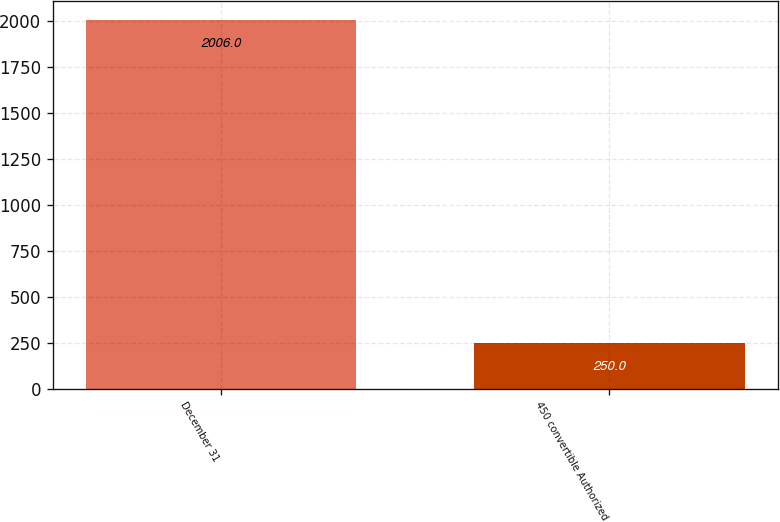Convert chart to OTSL. <chart><loc_0><loc_0><loc_500><loc_500><bar_chart><fcel>December 31<fcel>450 convertible Authorized<nl><fcel>2006<fcel>250<nl></chart> 